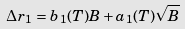Convert formula to latex. <formula><loc_0><loc_0><loc_500><loc_500>\Delta r _ { 1 } = b _ { 1 } ( T ) B + a _ { 1 } ( T ) \sqrt { B }</formula> 